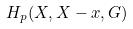<formula> <loc_0><loc_0><loc_500><loc_500>H _ { p } ( X , X - x , G )</formula> 